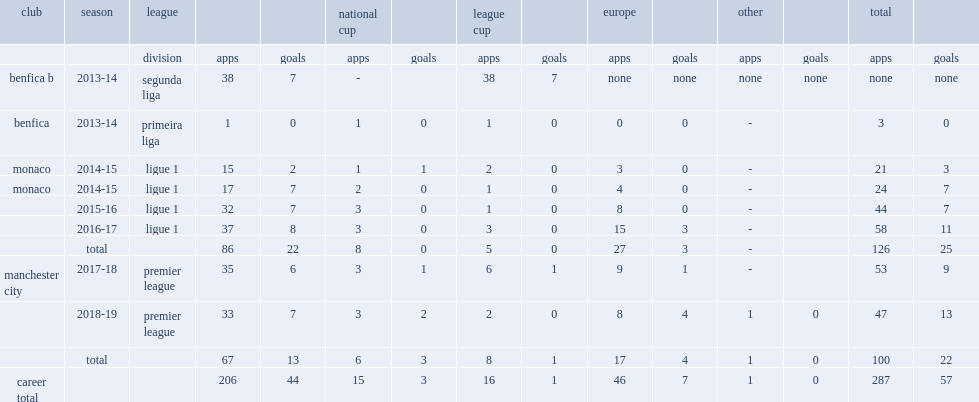In the 2014-15 season, which league was bernardo silva on loan to side of monaco? Ligue 1. 